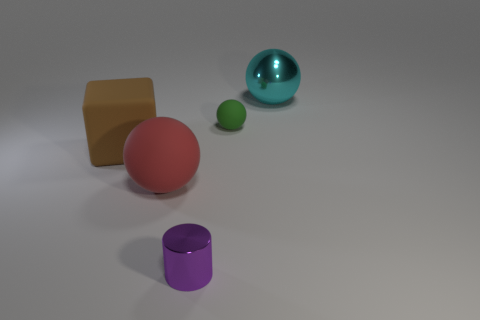What are the possible materials of the objects? Judging by their appearances, the objects could be made from various materials. The shiny cyan sphere looks like it's made of glass or polished stone, reflecting the environment. The purple cylinder has a metallic sheen and might be made of metal. The matte brown cube could be made of a material like wood or clay, and the smaller green sphere resembles a solid, opaque plastic or polished gemstone. 